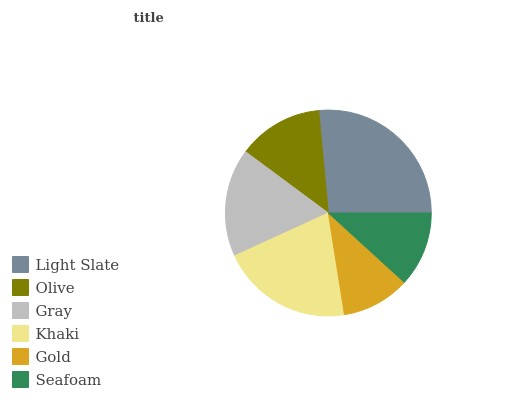Is Gold the minimum?
Answer yes or no. Yes. Is Light Slate the maximum?
Answer yes or no. Yes. Is Olive the minimum?
Answer yes or no. No. Is Olive the maximum?
Answer yes or no. No. Is Light Slate greater than Olive?
Answer yes or no. Yes. Is Olive less than Light Slate?
Answer yes or no. Yes. Is Olive greater than Light Slate?
Answer yes or no. No. Is Light Slate less than Olive?
Answer yes or no. No. Is Gray the high median?
Answer yes or no. Yes. Is Olive the low median?
Answer yes or no. Yes. Is Gold the high median?
Answer yes or no. No. Is Gold the low median?
Answer yes or no. No. 